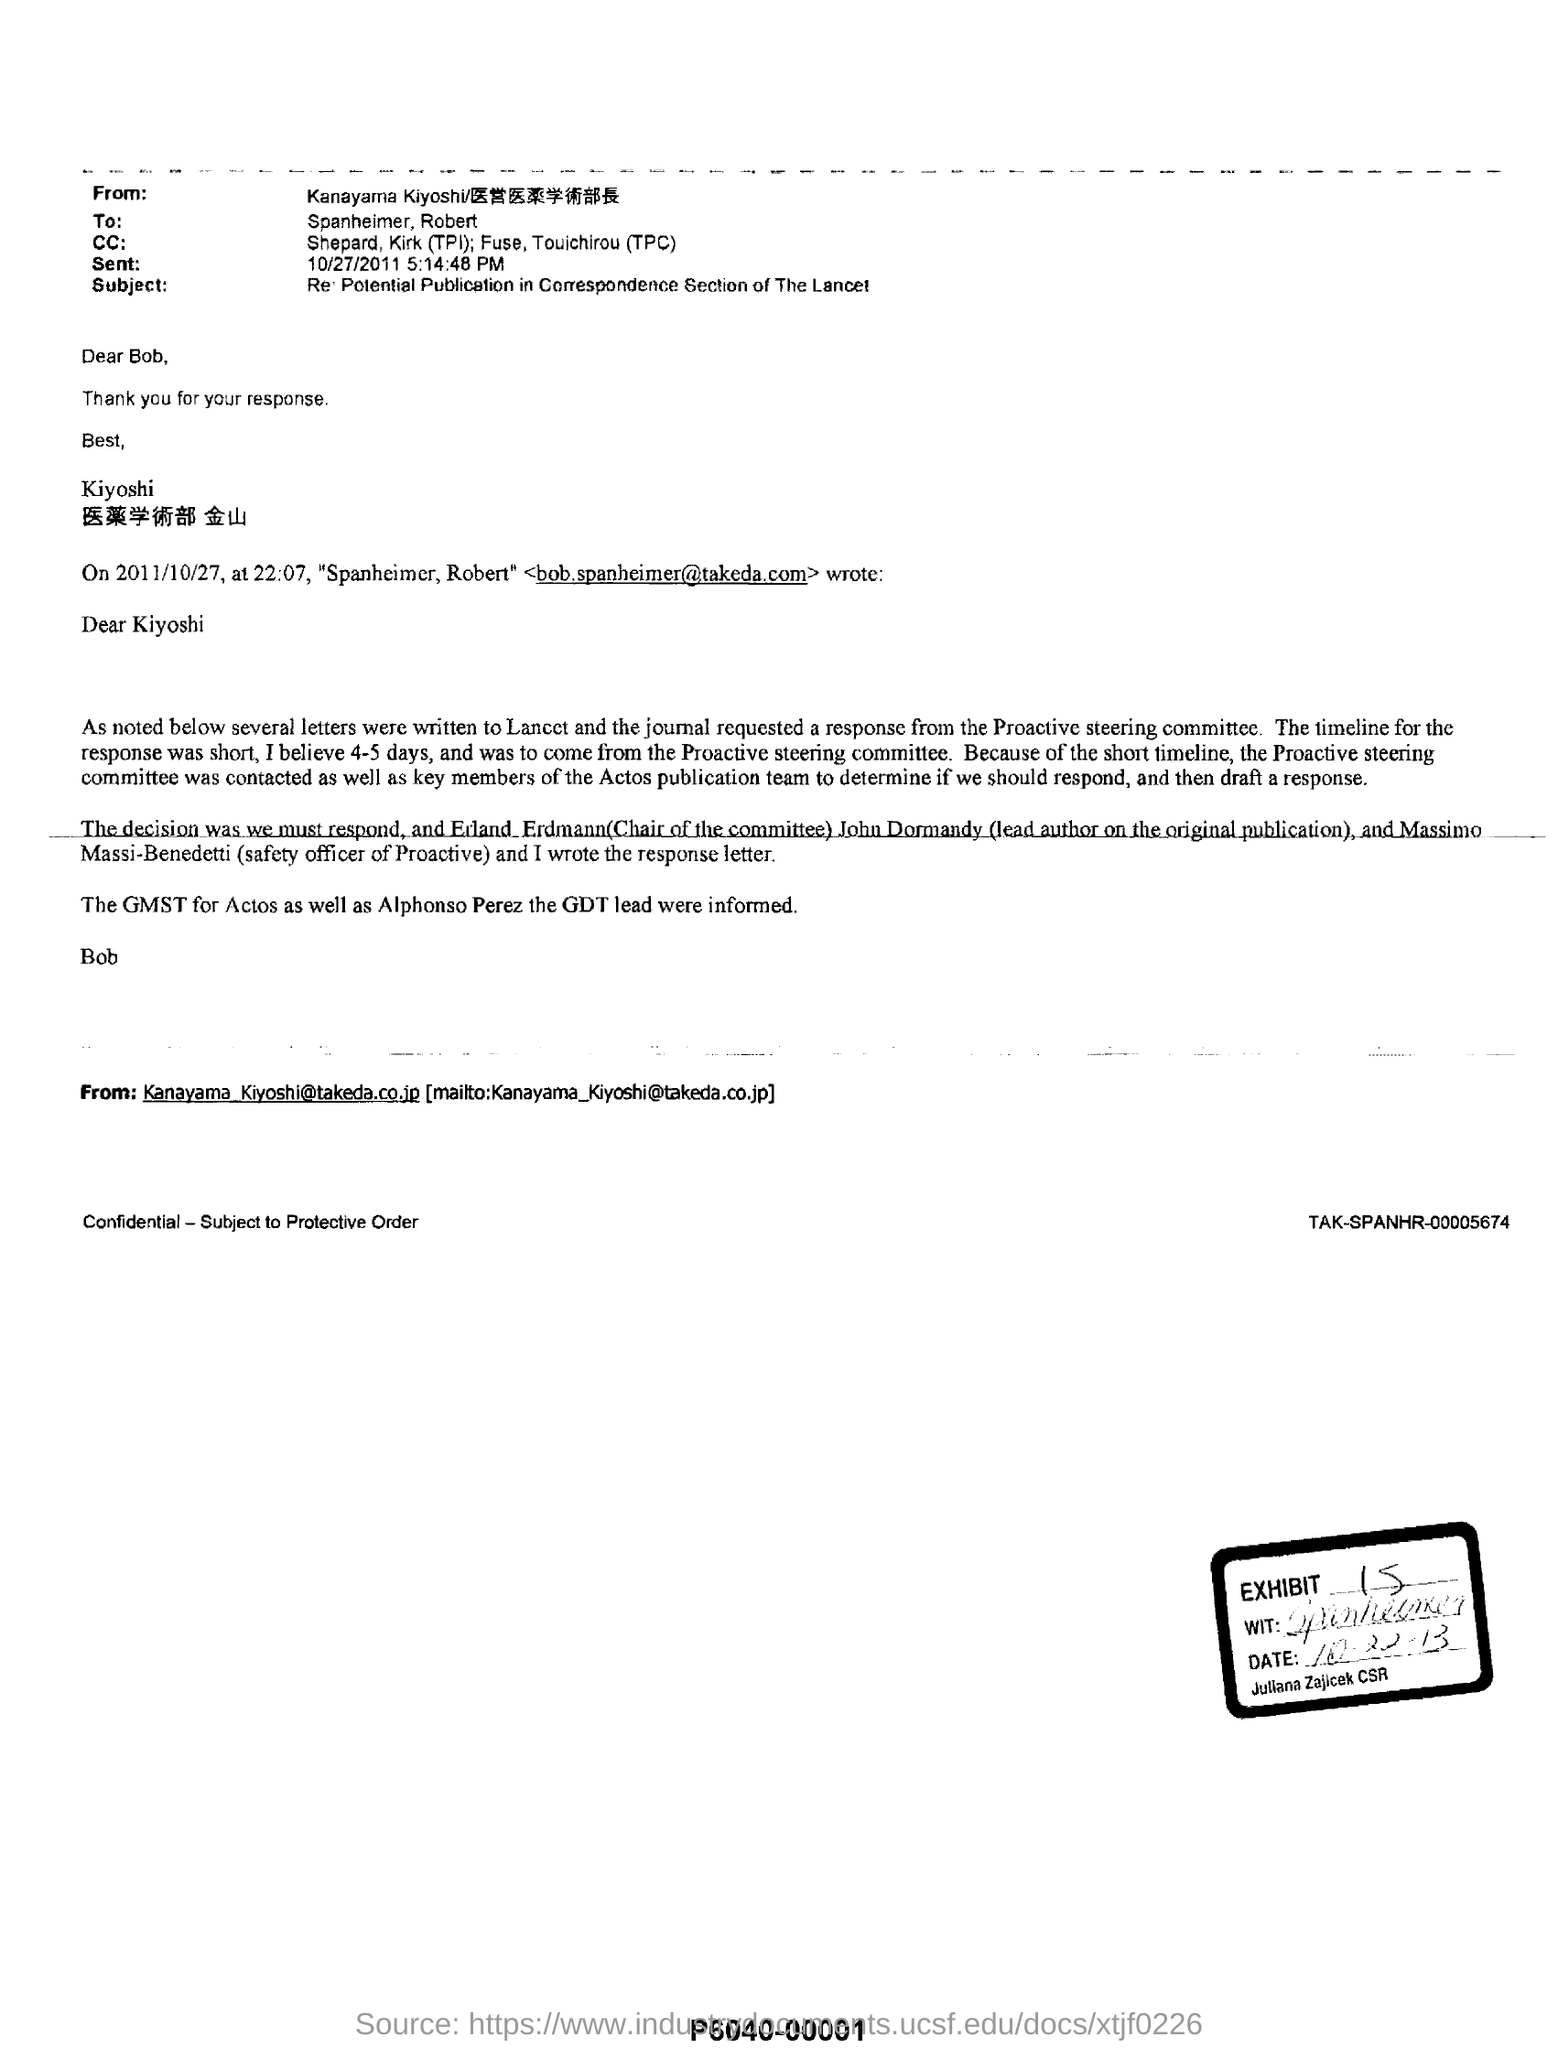From whom has this email been sent?
Your answer should be very brief. Kanayama Kiyoshi. Who are on the CC list?
Give a very brief answer. Shephard, Kirk (TPI); Fuse, Touichirou (TPC). What is the email ID of Kanayama Kiyoshi?
Offer a terse response. Kanayama_Kiyoshi@takeda.co.jp. What is the subject of this email?
Your answer should be compact. Re: Potential Publicaton in Correspondence Section of The Lancet. 